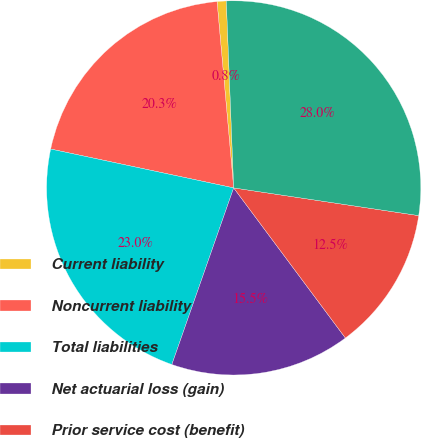Convert chart to OTSL. <chart><loc_0><loc_0><loc_500><loc_500><pie_chart><fcel>Current liability<fcel>Noncurrent liability<fcel>Total liabilities<fcel>Net actuarial loss (gain)<fcel>Prior service cost (benefit)<fcel>Total accumulated other<nl><fcel>0.79%<fcel>20.25%<fcel>22.97%<fcel>15.54%<fcel>12.45%<fcel>27.99%<nl></chart> 